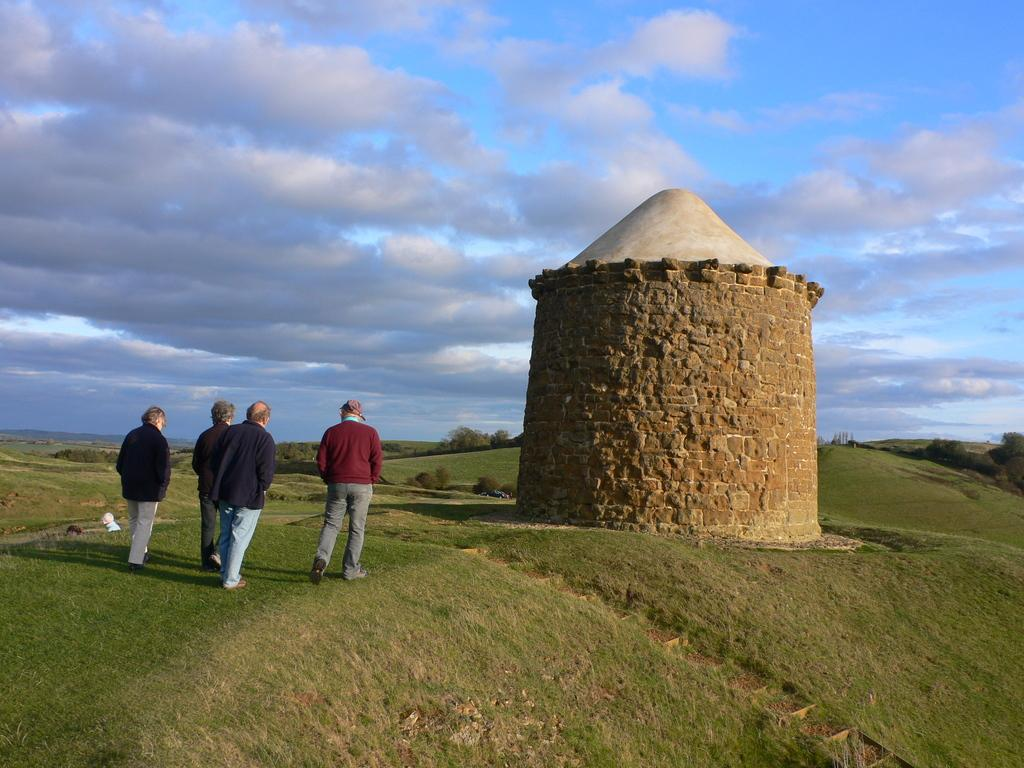What type of terrain is visible at the bottom of the image? There is grass at the bottom of the image. What can be seen in the foreground of the image? There are people and a fort in the foreground of the image. What type of landscape is visible in the background of the image? There are mountains and grass in the background of the image. What is visible at the top of the image? The sky is visible at the top of the image. Can you hear the people in the image laughing while standing in the quicksand? There is no quicksand present in the image, and it is not possible to hear the people in the image. 